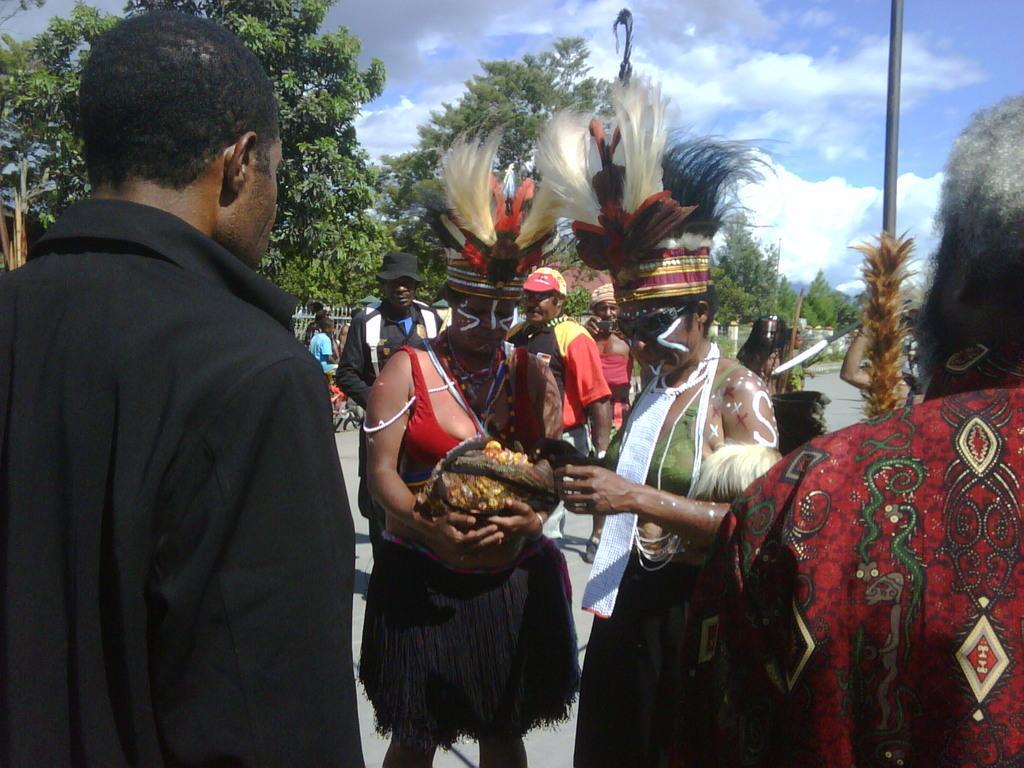Please provide a concise description of this image. In this image there are two persons who are wearing the costume are holding the basket. There is a man on the left side. At the top there is sky. In the background there are trees. On the right side there is another man who is holding the pole. 